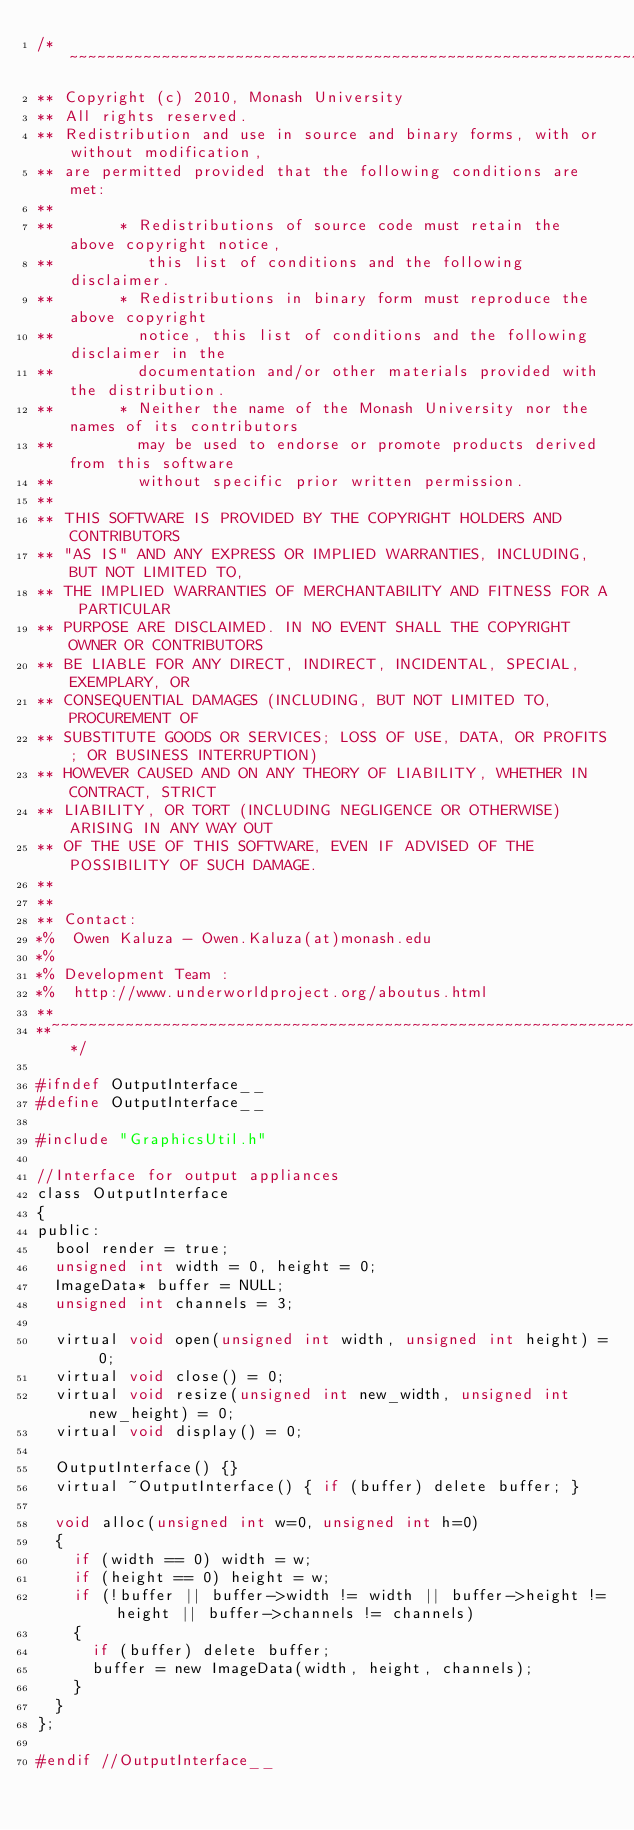<code> <loc_0><loc_0><loc_500><loc_500><_C_>/*~~~~~~~~~~~~~~~~~~~~~~~~~~~~~~~~~~~~~~~~~~~~~~~~~~~~~~~~~~~~~~~~~~~~~~~~~~~~~~~~~~~~~~~~~~~~~~~
** Copyright (c) 2010, Monash University
** All rights reserved.
** Redistribution and use in source and binary forms, with or without modification,
** are permitted provided that the following conditions are met:
**
**       * Redistributions of source code must retain the above copyright notice,
**          this list of conditions and the following disclaimer.
**       * Redistributions in binary form must reproduce the above copyright
**         notice, this list of conditions and the following disclaimer in the
**         documentation and/or other materials provided with the distribution.
**       * Neither the name of the Monash University nor the names of its contributors
**         may be used to endorse or promote products derived from this software
**         without specific prior written permission.
**
** THIS SOFTWARE IS PROVIDED BY THE COPYRIGHT HOLDERS AND CONTRIBUTORS
** "AS IS" AND ANY EXPRESS OR IMPLIED WARRANTIES, INCLUDING, BUT NOT LIMITED TO,
** THE IMPLIED WARRANTIES OF MERCHANTABILITY AND FITNESS FOR A PARTICULAR
** PURPOSE ARE DISCLAIMED. IN NO EVENT SHALL THE COPYRIGHT OWNER OR CONTRIBUTORS
** BE LIABLE FOR ANY DIRECT, INDIRECT, INCIDENTAL, SPECIAL, EXEMPLARY, OR
** CONSEQUENTIAL DAMAGES (INCLUDING, BUT NOT LIMITED TO, PROCUREMENT OF
** SUBSTITUTE GOODS OR SERVICES; LOSS OF USE, DATA, OR PROFITS; OR BUSINESS INTERRUPTION)
** HOWEVER CAUSED AND ON ANY THEORY OF LIABILITY, WHETHER IN CONTRACT, STRICT
** LIABILITY, OR TORT (INCLUDING NEGLIGENCE OR OTHERWISE) ARISING IN ANY WAY OUT
** OF THE USE OF THIS SOFTWARE, EVEN IF ADVISED OF THE POSSIBILITY OF SUCH DAMAGE.
**
**
** Contact:
*%  Owen Kaluza - Owen.Kaluza(at)monash.edu
*%
*% Development Team :
*%  http://www.underworldproject.org/aboutus.html
**
**~~~~~~~~~~~~~~~~~~~~~~~~~~~~~~~~~~~~~~~~~~~~~~~~~~~~~~~~~~~~~~~~~~~~~~~~~~~~~~~~~~~~~~~~~~~~~*/

#ifndef OutputInterface__
#define OutputInterface__

#include "GraphicsUtil.h"

//Interface for output appliances
class OutputInterface
{
public:
  bool render = true;
  unsigned int width = 0, height = 0;
  ImageData* buffer = NULL;
  unsigned int channels = 3;

  virtual void open(unsigned int width, unsigned int height) = 0;
  virtual void close() = 0;
  virtual void resize(unsigned int new_width, unsigned int new_height) = 0;
  virtual void display() = 0;

  OutputInterface() {}
  virtual ~OutputInterface() { if (buffer) delete buffer; }

  void alloc(unsigned int w=0, unsigned int h=0)
  {
    if (width == 0) width = w;
    if (height == 0) height = w;
    if (!buffer || buffer->width != width || buffer->height != height || buffer->channels != channels)
    {
      if (buffer) delete buffer;
      buffer = new ImageData(width, height, channels);
    }
  }
};

#endif //OutputInterface__
</code> 